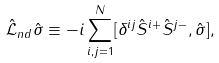<formula> <loc_0><loc_0><loc_500><loc_500>\hat { \mathcal { L } } _ { n d } \hat { \sigma } \equiv - i \sum _ { i , j = 1 } ^ { N } [ \delta ^ { i j } \hat { S } ^ { i + } \hat { S } ^ { j - } , \hat { \sigma } ] ,</formula> 